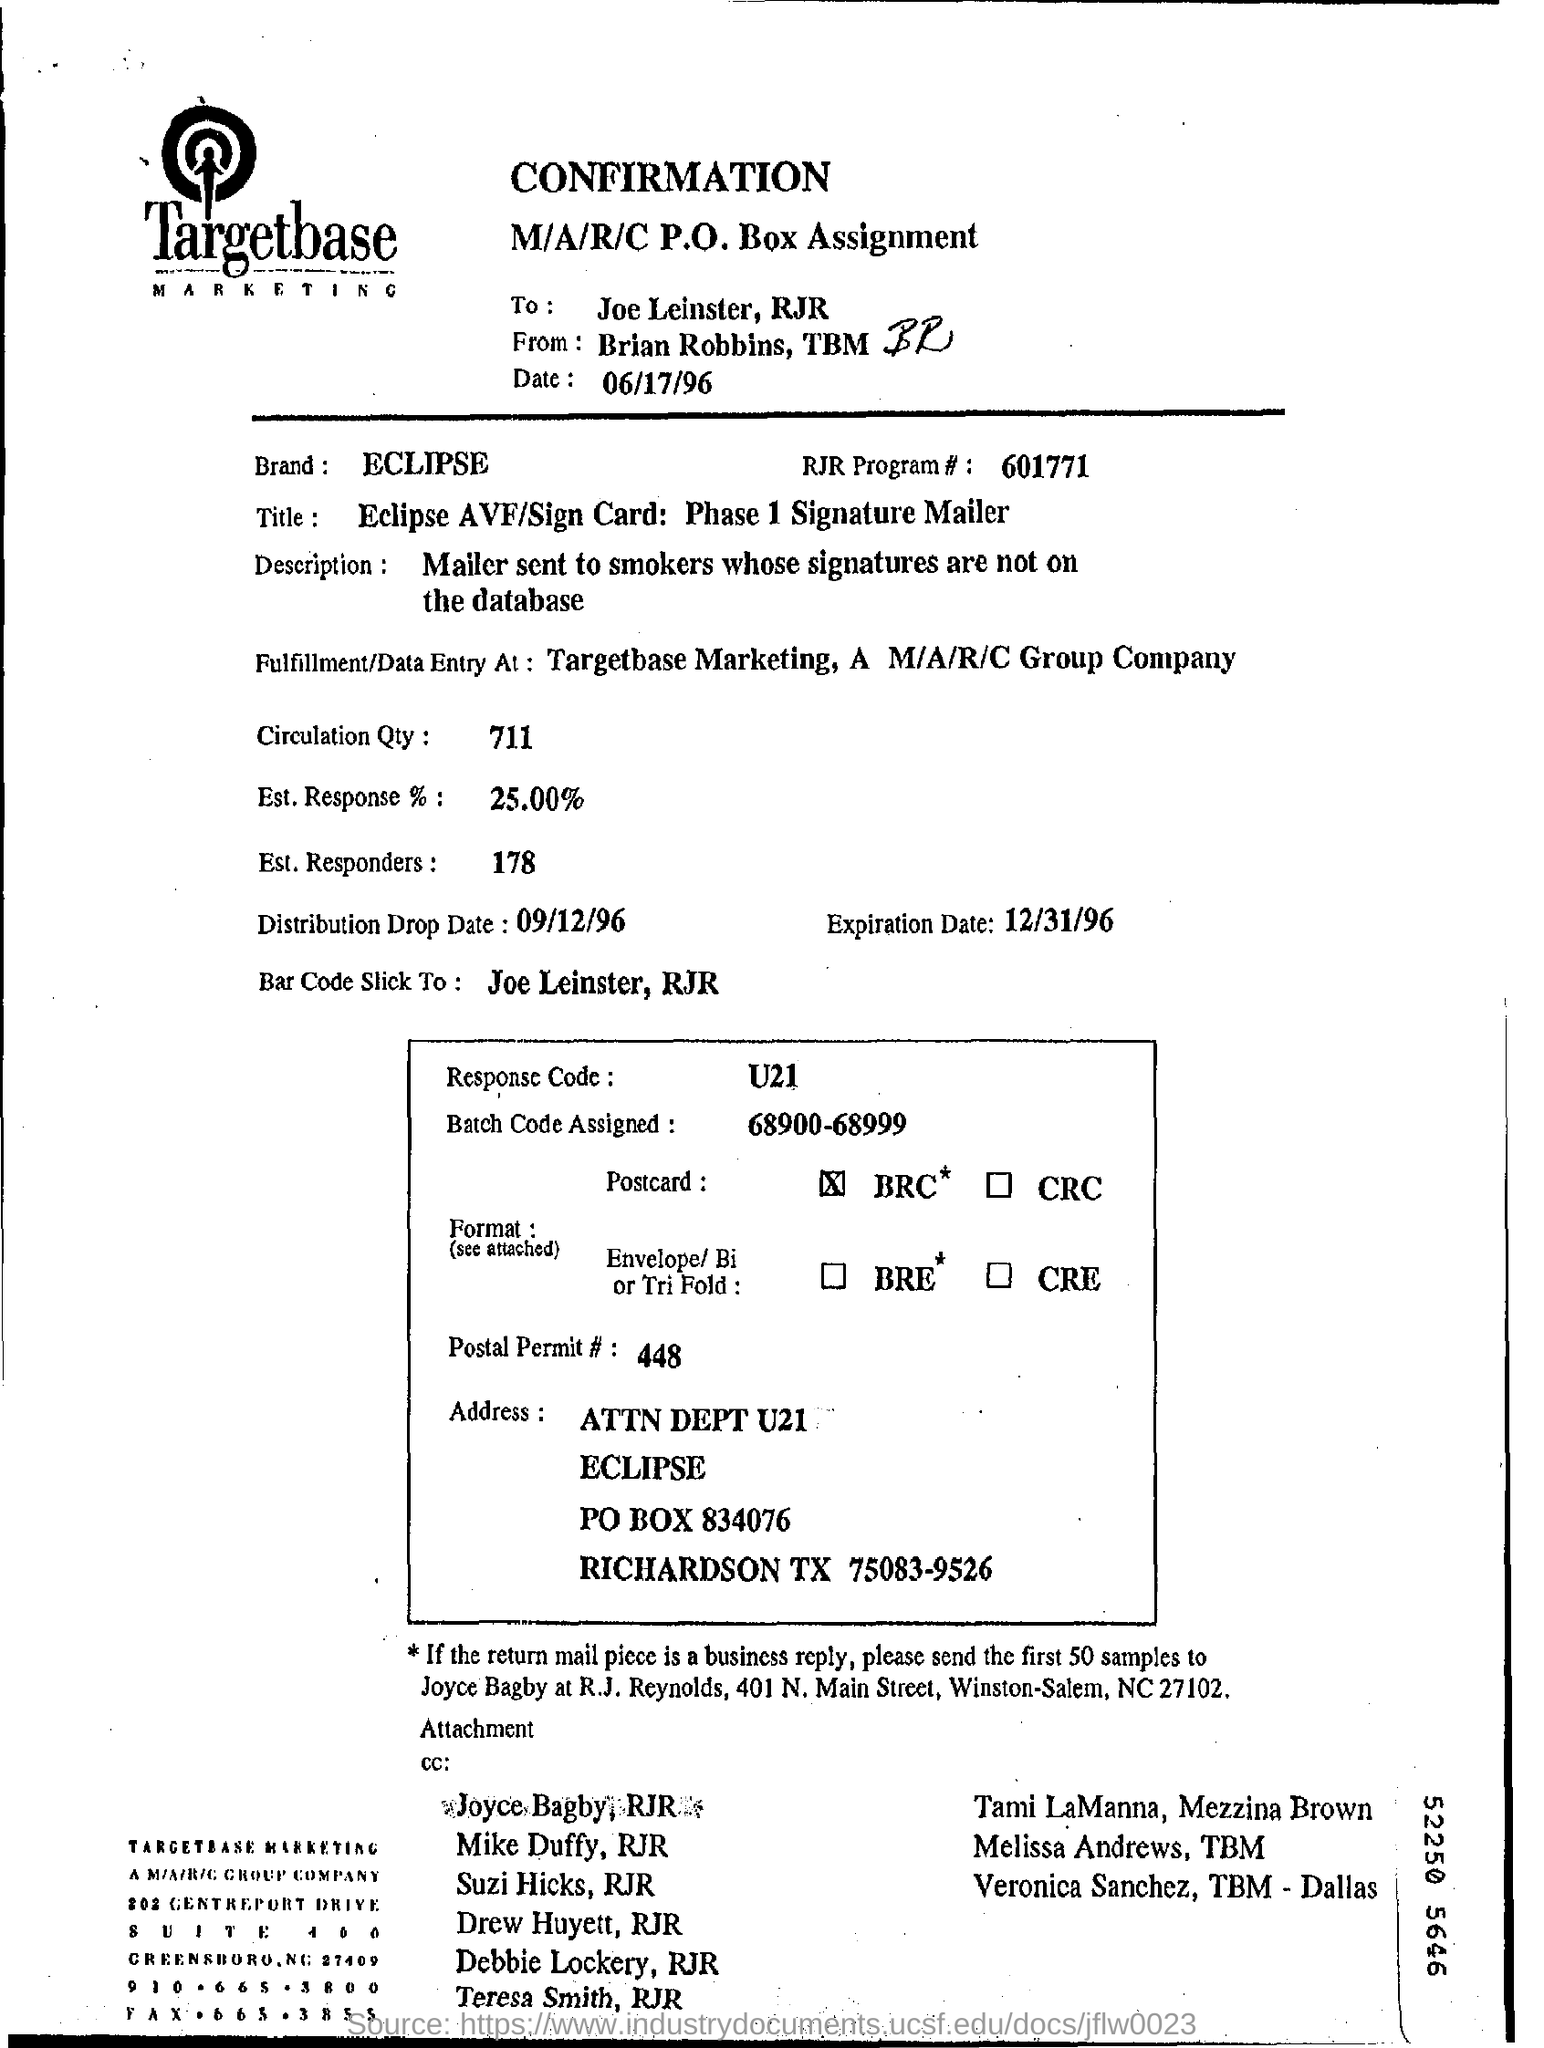Draw attention to some important aspects in this diagram. The brand mentioned in this document is ECLIPSE. The response code mentioned in the document is U21. The batch code assigned is 68900-68999. The document is addressed to Joe Leinster and RJR. The estimated response rate is 25.00%, as per the provided document. 